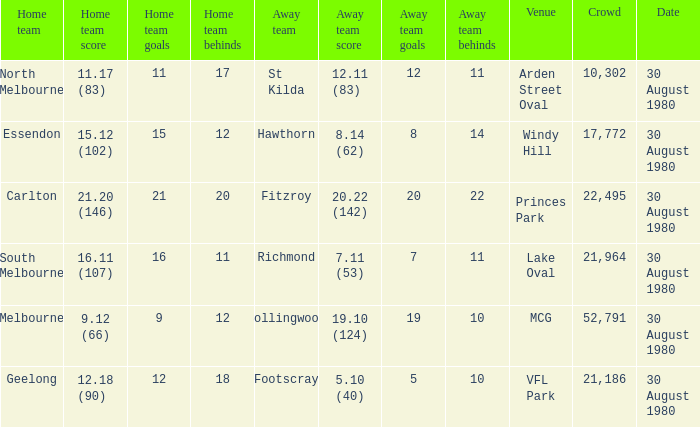What was the score for south melbourne at home? 16.11 (107). Could you parse the entire table? {'header': ['Home team', 'Home team score', 'Home team goals', 'Home team behinds', 'Away team', 'Away team score', 'Away team goals', 'Away team behinds', 'Venue', 'Crowd', 'Date'], 'rows': [['North Melbourne', '11.17 (83)', '11', '17', 'St Kilda', '12.11 (83)', '12', '11', 'Arden Street Oval', '10,302', '30 August 1980'], ['Essendon', '15.12 (102)', '15', '12', 'Hawthorn', '8.14 (62)', '8', '14', 'Windy Hill', '17,772', '30 August 1980'], ['Carlton', '21.20 (146)', '21', '20', 'Fitzroy', '20.22 (142)', '20', '22', 'Princes Park', '22,495', '30 August 1980'], ['South Melbourne', '16.11 (107)', '16', '11', 'Richmond', '7.11 (53)', '7', '11', 'Lake Oval', '21,964', '30 August 1980'], ['Melbourne', '9.12 (66)', '9', '12', 'Collingwood', '19.10 (124)', '19', '10', 'MCG', '52,791', '30 August 1980'], ['Geelong', '12.18 (90)', '12', '18', 'Footscray', '5.10 (40)', '5', '10', 'VFL Park', '21,186', '30 August 1980']]} 